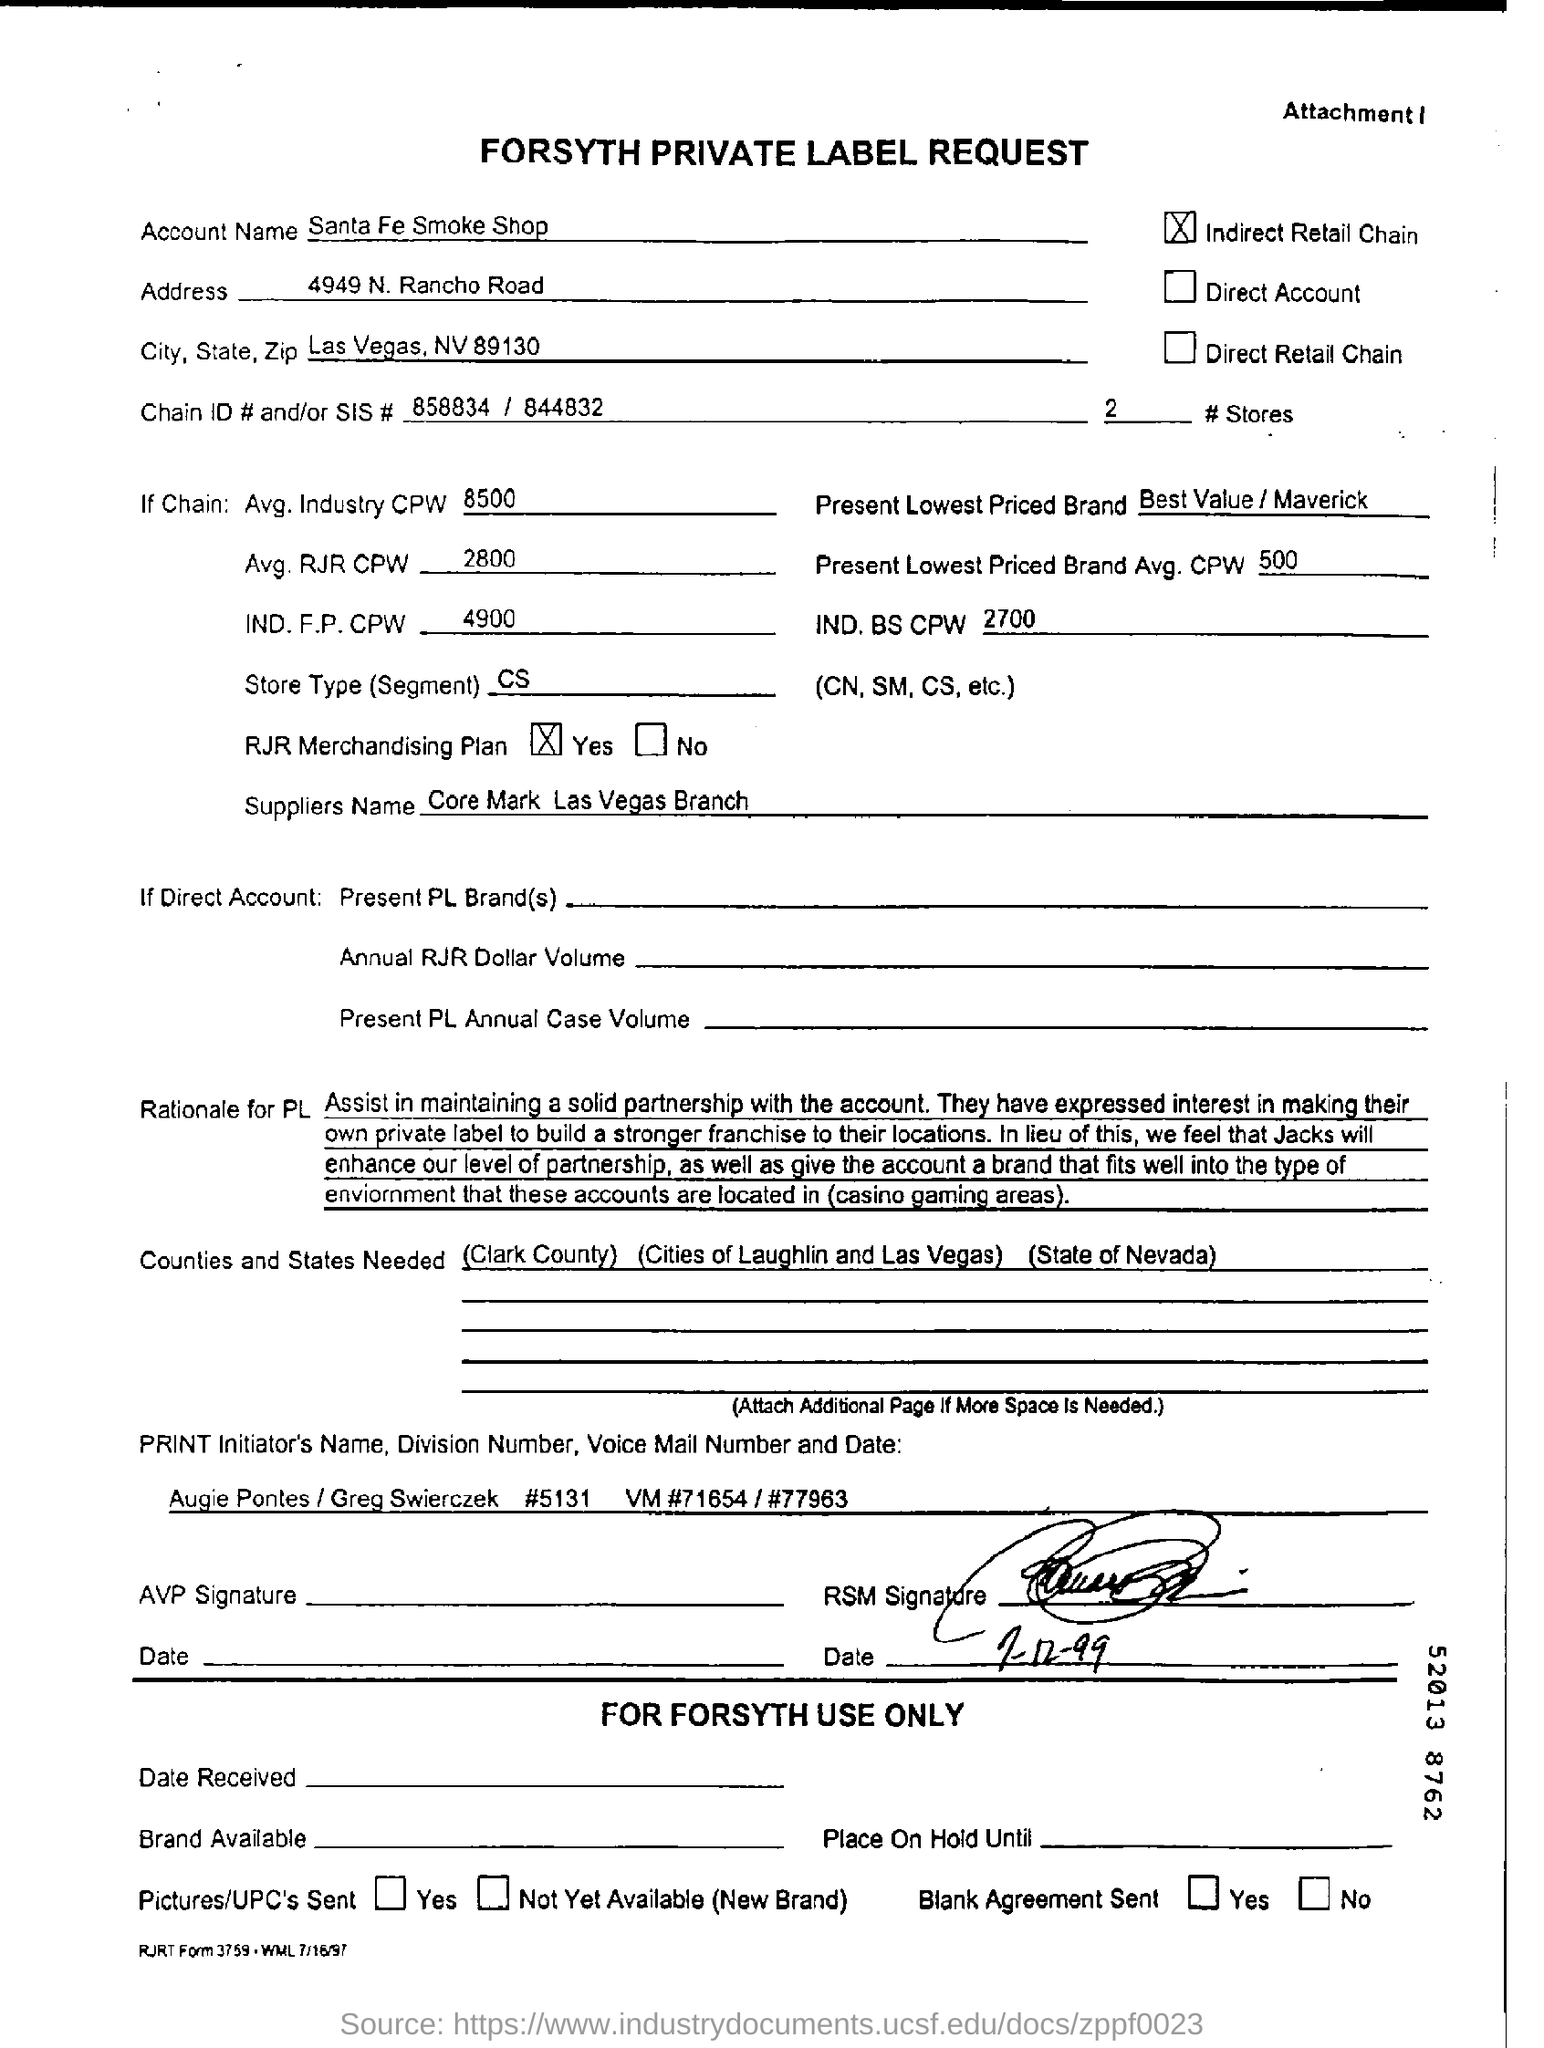What is the document title?
Your response must be concise. Forsyth Private Label Request. What is the account name?
Give a very brief answer. Santa Fe Smoke Shop. 